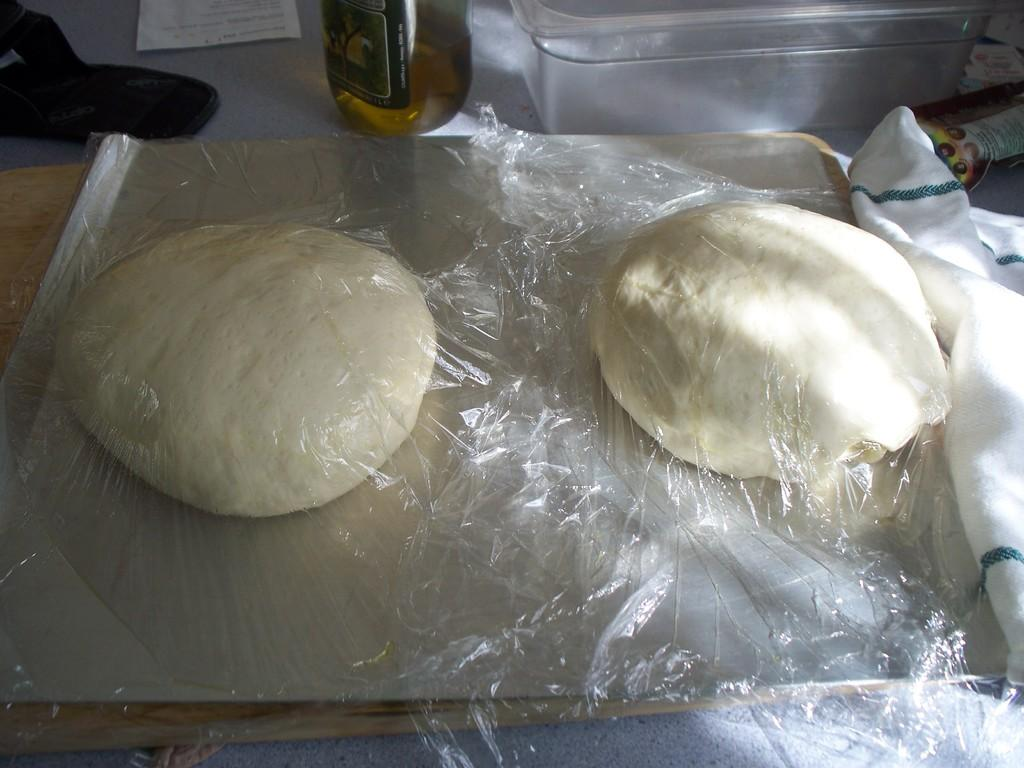What is in the tray that is visible in the image? There is flour dough in a tray in the image. How is the tray being protected in the image? The tray is covered with a cover. Where is the tray located in the image? The tray is placed on a table. What other items can be seen in the image? There is a bottle, a paper, a container, and a cloth in the image. Can you see a cat playing with a cord in the image? There is no cat or cord present in the image. 